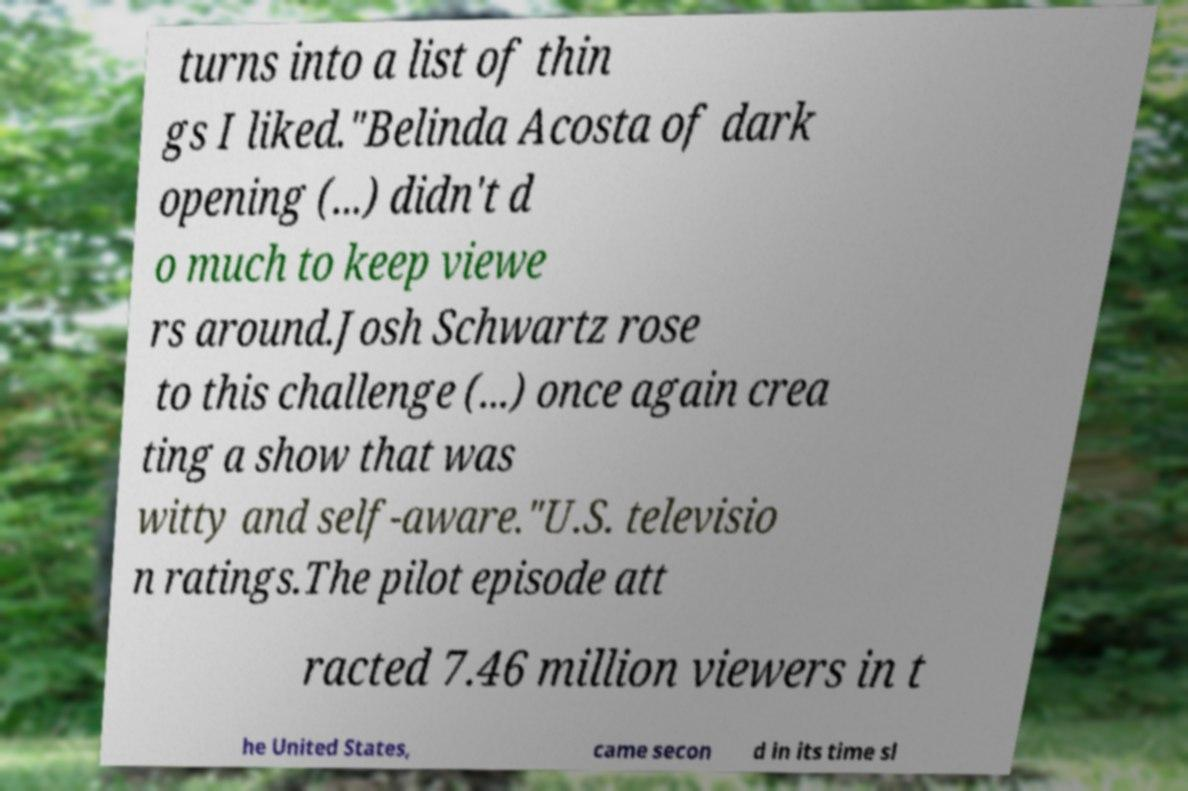Please read and relay the text visible in this image. What does it say? turns into a list of thin gs I liked."Belinda Acosta of dark opening (...) didn't d o much to keep viewe rs around.Josh Schwartz rose to this challenge (...) once again crea ting a show that was witty and self-aware."U.S. televisio n ratings.The pilot episode att racted 7.46 million viewers in t he United States, came secon d in its time sl 